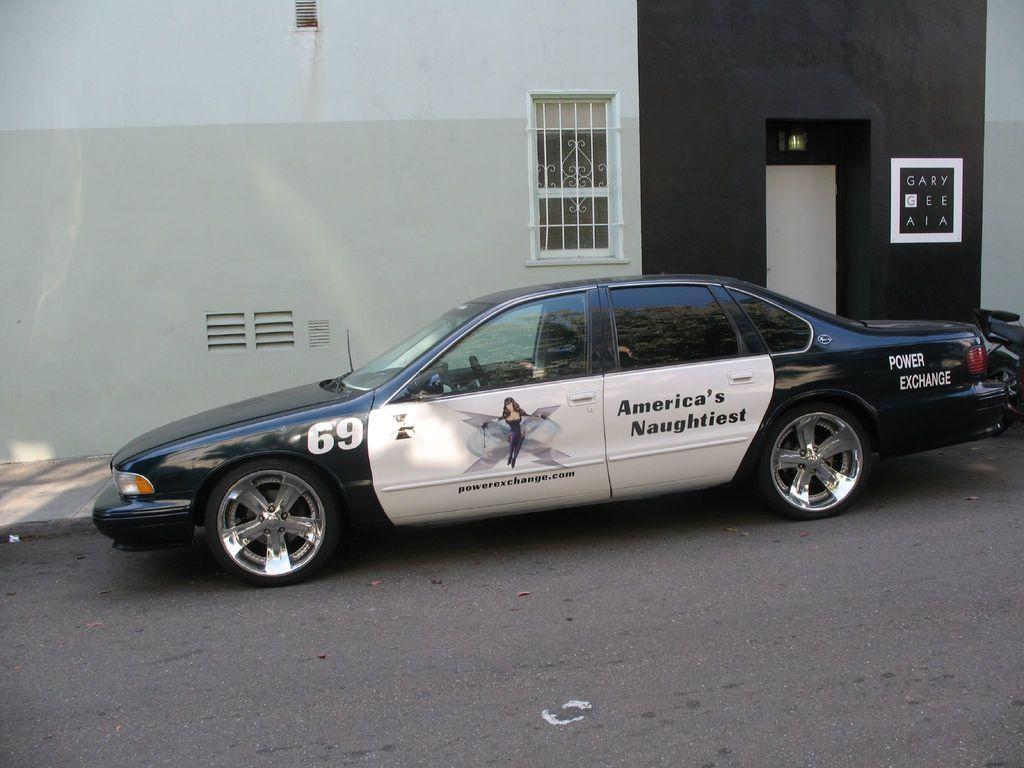Could you give a brief overview of what you see in this image? In this image we can see a car on the road. In the background there is a building. 